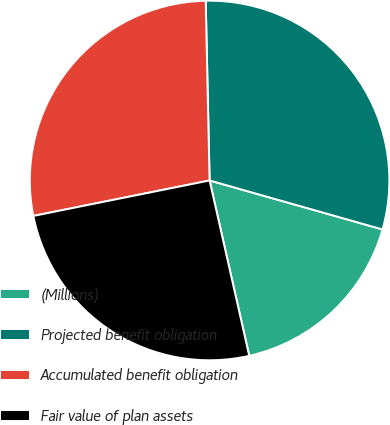Convert chart to OTSL. <chart><loc_0><loc_0><loc_500><loc_500><pie_chart><fcel>(Millions)<fcel>Projected benefit obligation<fcel>Accumulated benefit obligation<fcel>Fair value of plan assets<nl><fcel>17.07%<fcel>29.74%<fcel>27.82%<fcel>25.38%<nl></chart> 